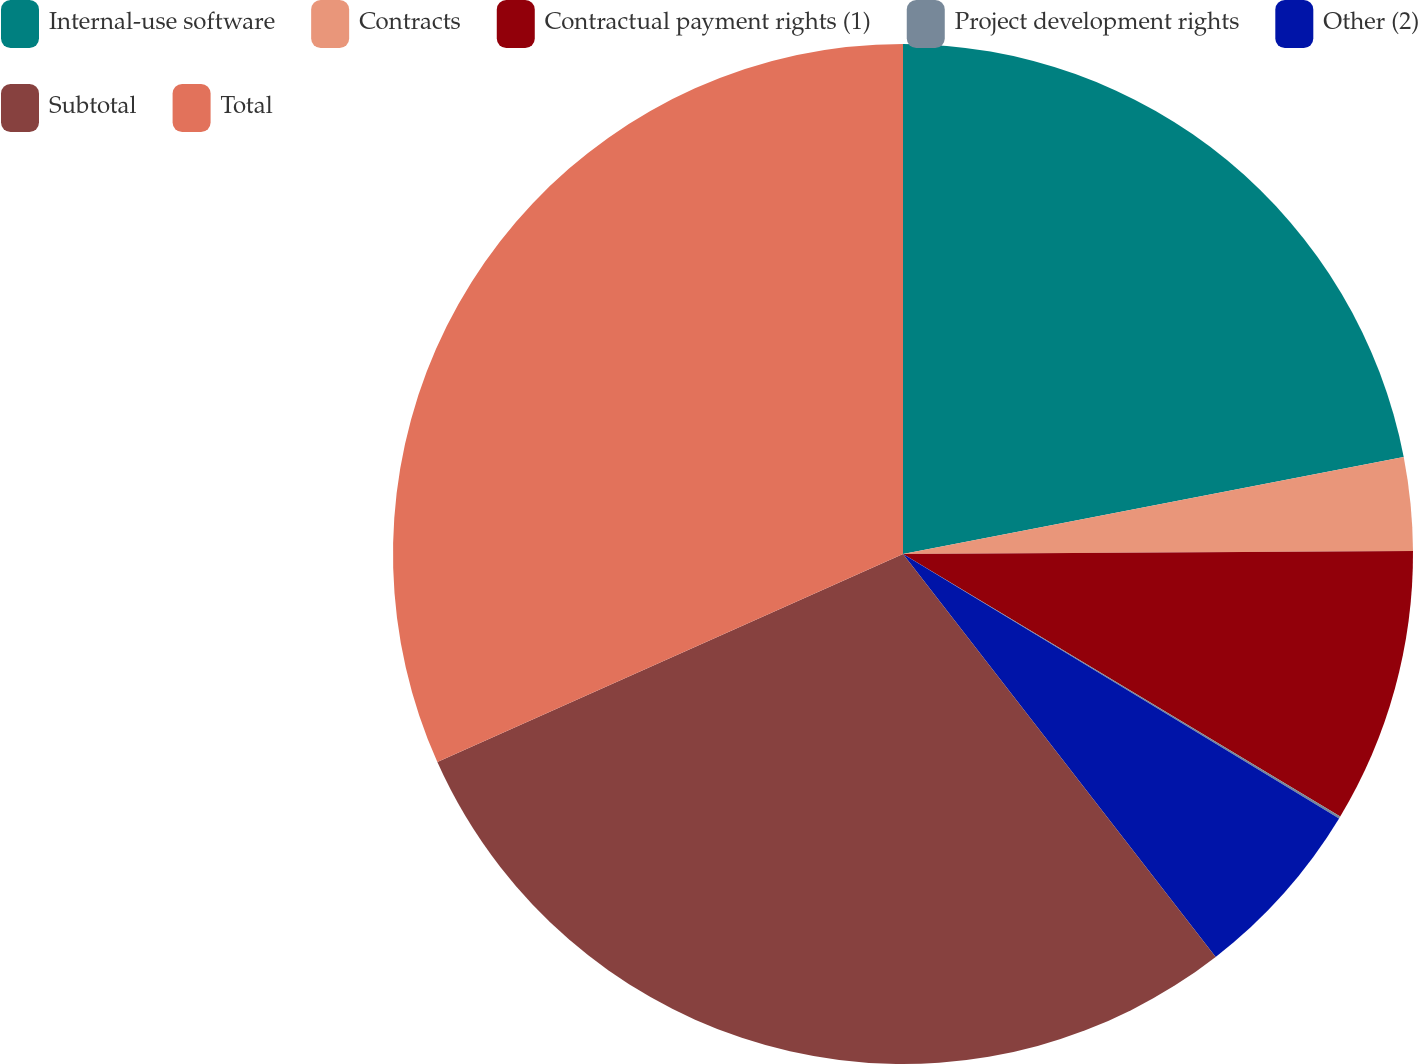Convert chart. <chart><loc_0><loc_0><loc_500><loc_500><pie_chart><fcel>Internal-use software<fcel>Contracts<fcel>Contractual payment rights (1)<fcel>Project development rights<fcel>Other (2)<fcel>Subtotal<fcel>Total<nl><fcel>21.96%<fcel>2.95%<fcel>8.7%<fcel>0.07%<fcel>5.82%<fcel>28.82%<fcel>31.69%<nl></chart> 